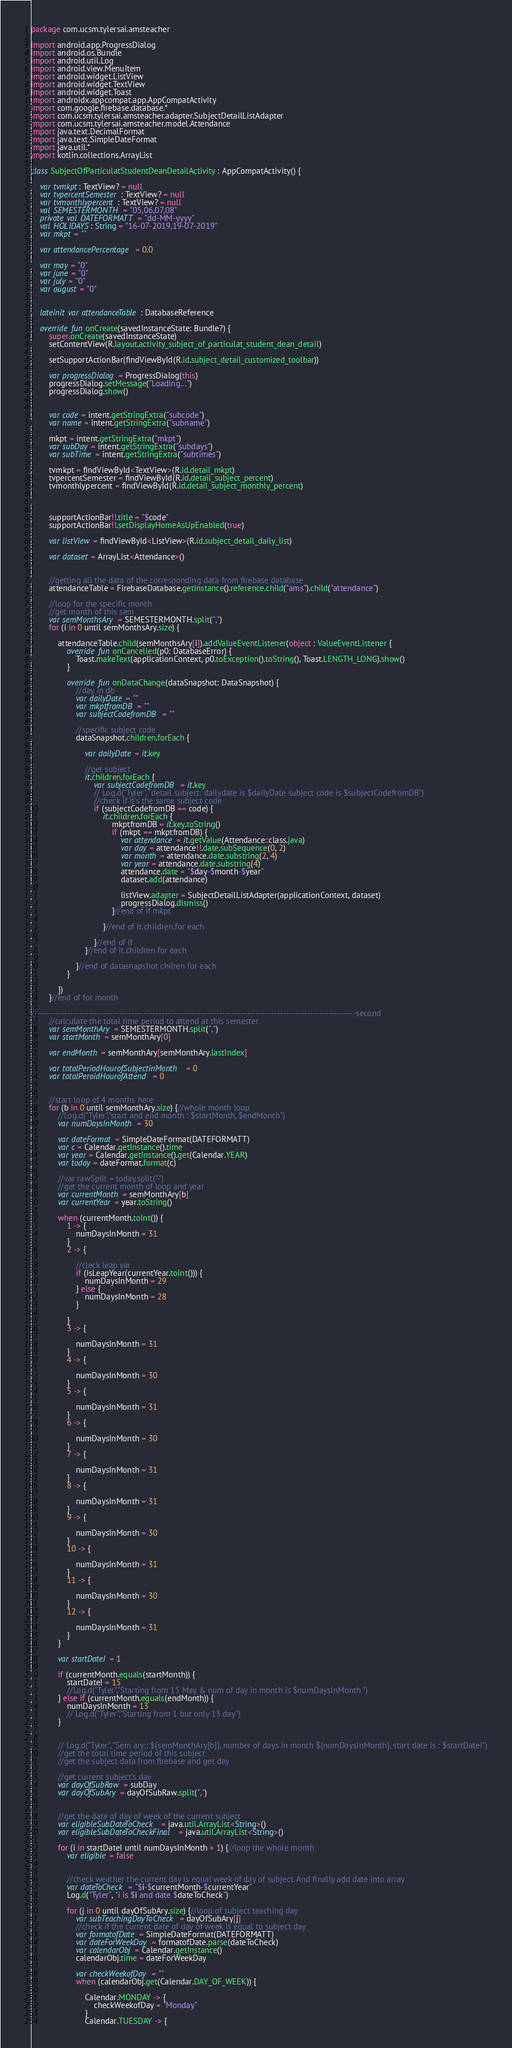<code> <loc_0><loc_0><loc_500><loc_500><_Kotlin_>package com.ucsm.tylersai.amsteacher

import android.app.ProgressDialog
import android.os.Bundle
import android.util.Log
import android.view.MenuItem
import android.widget.ListView
import android.widget.TextView
import android.widget.Toast
import androidx.appcompat.app.AppCompatActivity
import com.google.firebase.database.*
import com.ucsm.tylersai.amsteacher.adapter.SubjectDetailListAdapter
import com.ucsm.tylersai.amsteacher.model.Attendance
import java.text.DecimalFormat
import java.text.SimpleDateFormat
import java.util.*
import kotlin.collections.ArrayList

class SubjectOfParticulatStudentDeanDetailActivity : AppCompatActivity() {

    var tvmkpt: TextView? = null
    var tvpercentSemester: TextView? = null
    var tvmonthlypercent: TextView? = null
    val SEMESTERMONTH = "05,06,07,08"
    private val DATEFORMATT = "dd-MM-yyyy"
    val HOLIDAYS: String = "16-07-2019,19-07-2019"
    var mkpt = ""

    var attendancePercentage = 0.0

    var may = "0"
    var june = "0"
    var july = "0"
    var august = "0"


    lateinit var attendanceTable: DatabaseReference

    override fun onCreate(savedInstanceState: Bundle?) {
        super.onCreate(savedInstanceState)
        setContentView(R.layout.activity_subject_of_particulat_student_dean_detail)

        setSupportActionBar(findViewById(R.id.subject_detail_customized_toolbar))

        var progressDialog = ProgressDialog(this)
        progressDialog.setMessage("Loading...")
        progressDialog.show()


        var code = intent.getStringExtra("subcode")
        var name = intent.getStringExtra("subname")

        mkpt = intent.getStringExtra("mkpt")
        var subDay = intent.getStringExtra("subdays")
        var subTime = intent.getStringExtra("subtimes")

        tvmkpt = findViewById<TextView>(R.id.detail_mkpt)
        tvpercentSemester = findViewById(R.id.detail_subject_percent)
        tvmonthlypercent = findViewById(R.id.detail_subject_monthly_percent)



        supportActionBar!!.title = "$code"
        supportActionBar!!.setDisplayHomeAsUpEnabled(true)

        var listView = findViewById<ListView>(R.id.subject_detail_daily_list)

        var dataset = ArrayList<Attendance>()


        //getting all the data of the corresponding data from firebase database
        attendanceTable = FirebaseDatabase.getInstance().reference.child("ams").child("attendance")

        //loop for the specific month
        //get month of this sem
        var semMonthsAry = SEMESTERMONTH.split(",")
        for (i in 0 until semMonthsAry.size) {

            attendanceTable.child(semMonthsAry[i]).addValueEventListener(object : ValueEventListener {
                override fun onCancelled(p0: DatabaseError) {
                    Toast.makeText(applicationContext, p0.toException().toString(), Toast.LENGTH_LONG).show()
                }

                override fun onDataChange(dataSnapshot: DataSnapshot) {
                    //day in db
                    var dailyDate = ""
                    var mkptfromDB = ""
                    var subjectCodefromDB = ""

                    //specific subject code
                    dataSnapshot.children.forEach {

                        var dailyDate = it.key

                        //get subject
                        it.children.forEach {
                            var subjectCodefromDB = it.key
                            // Log.d("Tyler", "detail subject: dailydate is $dailyDate subject code is $subjectCodefromDB")
                            //check if it's the same subject code
                            if (subjectCodefromDB == code) {
                                it.children.forEach {
                                    mkptfromDB = it.key.toString()
                                    if (mkpt == mkptfromDB) {
                                        var attendance = it.getValue(Attendance::class.java)
                                        var day = attendance!!.date.subSequence(0, 2)
                                        var month = attendance.date.substring(2, 4)
                                        var year = attendance.date.substring(4)
                                        attendance.date = "$day-$month-$year"
                                        dataset.add(attendance)

                                        listView.adapter = SubjectDetailListAdapter(applicationContext, dataset)
                                        progressDialog.dismiss()
                                    }//end of if mkpt

                                }//end of it.children.for each

                            }//end of if
                        }//end of it.children for each

                    }//end of datasnapshot chilren for each
                }

            })
        }//end of for month

//---------------------------------------------------------------------------------------------------------second
        //calculate the total time period to attend at this semester
        var semMonthAry = SEMESTERMONTH.split(",")
        var startMonth = semMonthAry[0]

        var endMonth = semMonthAry[semMonthAry.lastIndex]

        var totalPeriodHourofSubjectinMonth = 0
        var totalPeroidHourofAttend = 0


        //start loop of 4 months here
        for (b in 0 until semMonthAry.size) {//whole month loop
            //Log.d("Tyler","start and end month : $startMonth, $endMonth")
            var numDaysInMonth = 30

            var dateFormat = SimpleDateFormat(DATEFORMATT)
            var c = Calendar.getInstance().time
            var year = Calendar.getInstance().get(Calendar.YEAR)
            var today = dateFormat.format(c)

            //var rawSplit = today.split("-")
            //get the current month of loop and year
            var currentMonth = semMonthAry[b]
            var currentYear = year.toString()

            when (currentMonth.toInt()) {
                1 -> {
                    numDaysInMonth = 31
                }
                2 -> {

                    //cleck leap yar
                    if (isLeapYear(currentYear.toInt())) {
                        numDaysInMonth = 29
                    } else {
                        numDaysInMonth = 28
                    }

                }
                3 -> {

                    numDaysInMonth = 31
                }
                4 -> {

                    numDaysInMonth = 30
                }
                5 -> {

                    numDaysInMonth = 31
                }
                6 -> {

                    numDaysInMonth = 30
                }
                7 -> {

                    numDaysInMonth = 31
                }
                8 -> {

                    numDaysInMonth = 31
                }
                9 -> {

                    numDaysInMonth = 30
                }
                10 -> {

                    numDaysInMonth = 31
                }
                11 -> {

                    numDaysInMonth = 30
                }
                12 -> {

                    numDaysInMonth = 31
                }
            }

            var startDateI = 1

            if (currentMonth.equals(startMonth)) {
                startDateI = 15
                //Log.d("Tyler","Starting from 15 May & num of day in month is $numDaysInMonth ")
            } else if (currentMonth.equals(endMonth)) {
                numDaysInMonth = 13
                // Log.d("Tyler","Starting from 1 but only 13 day")
            }


            // Log.d("Tyler", "Sem ary:: ${semMonthAry[b]}, number of days in month ${numDaysInMonth}, start date is : $startDateI")
            //get the total time period of this subject
            //get the subject data from firebase and get day

            //get current subject's day
            var dayOfSubRaw = subDay
            var dayOfSubAry = dayOfSubRaw.split(",")


            //get the date of day of week of the current subject
            var eligibleSubDateToCheck = java.util.ArrayList<String>()
            var eligibleSubDateToCheckFinal = java.util.ArrayList<String>()

            for (i in startDateI until numDaysInMonth + 1) {//loop the whole month
                var eligible = false


                //check weather the current day is equal week of day of subject. And finally add date into array
                var dateToCheck = "$i-$currentMonth-$currentYear"
                Log.d("Tyler", "i is $i and date $dateToCheck")

                for (j in 0 until dayOfSubAry.size) {//loop of subject teaching day
                    var subTeachingDayToCheck = dayOfSubAry[j]
                    //check if the current date of day of week is equal to subject day
                    var formatofDate = SimpleDateFormat(DATEFORMATT)
                    var dateForWeekDay = formatofDate.parse(dateToCheck)
                    var calendarObj = Calendar.getInstance()
                    calendarObj.time = dateForWeekDay

                    var checkWeekofDay = ""
                    when (calendarObj.get(Calendar.DAY_OF_WEEK)) {

                        Calendar.MONDAY -> {
                            checkWeekofDay = "Monday"
                        }
                        Calendar.TUESDAY -> {</code> 